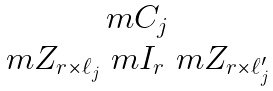Convert formula to latex. <formula><loc_0><loc_0><loc_500><loc_500>\begin{matrix} \ m C _ { j } \\ \ m Z _ { r \times \ell _ { j } } \ m I _ { r } \ m Z _ { r \times \ell ^ { \prime } _ { j } } \end{matrix}</formula> 